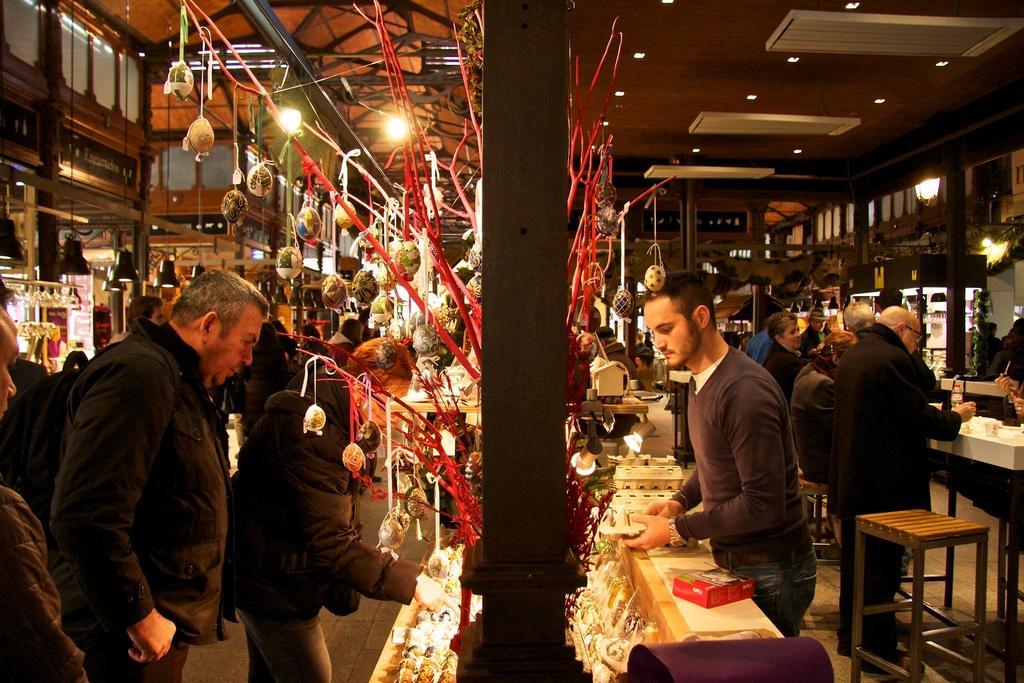Can you describe this image briefly? The persons wearing black dress is looking at some object in the shop and there are group of people in front of him and there are some stores behind him. 